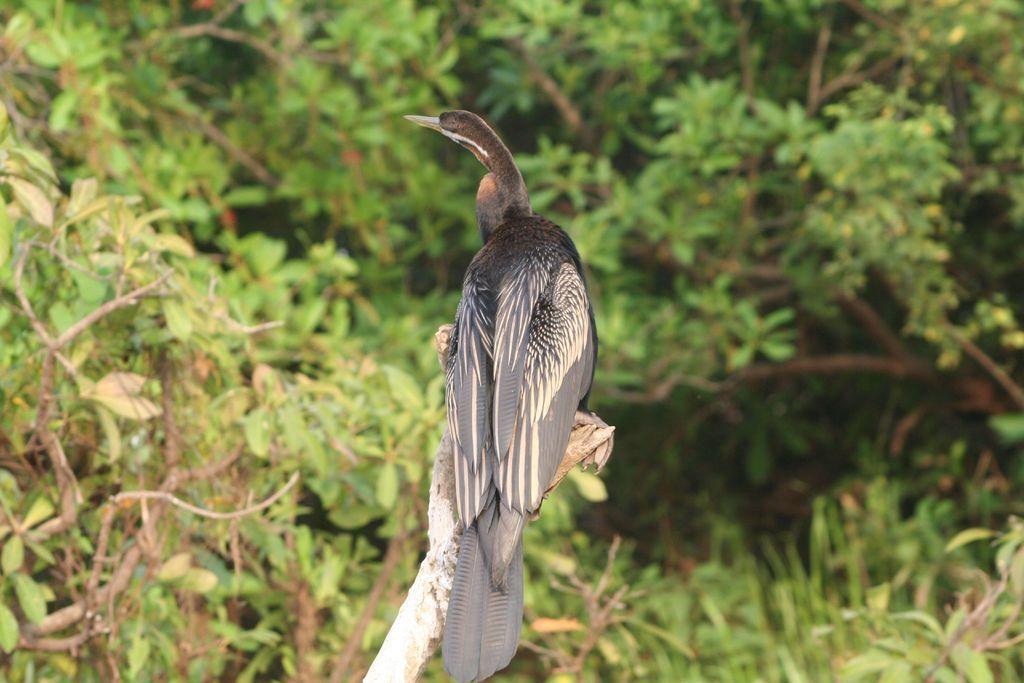Could you give a brief overview of what you see in this image? This image is taken outdoors. In the background there are many trees. In the middle of the image there is a bird on the bark. 